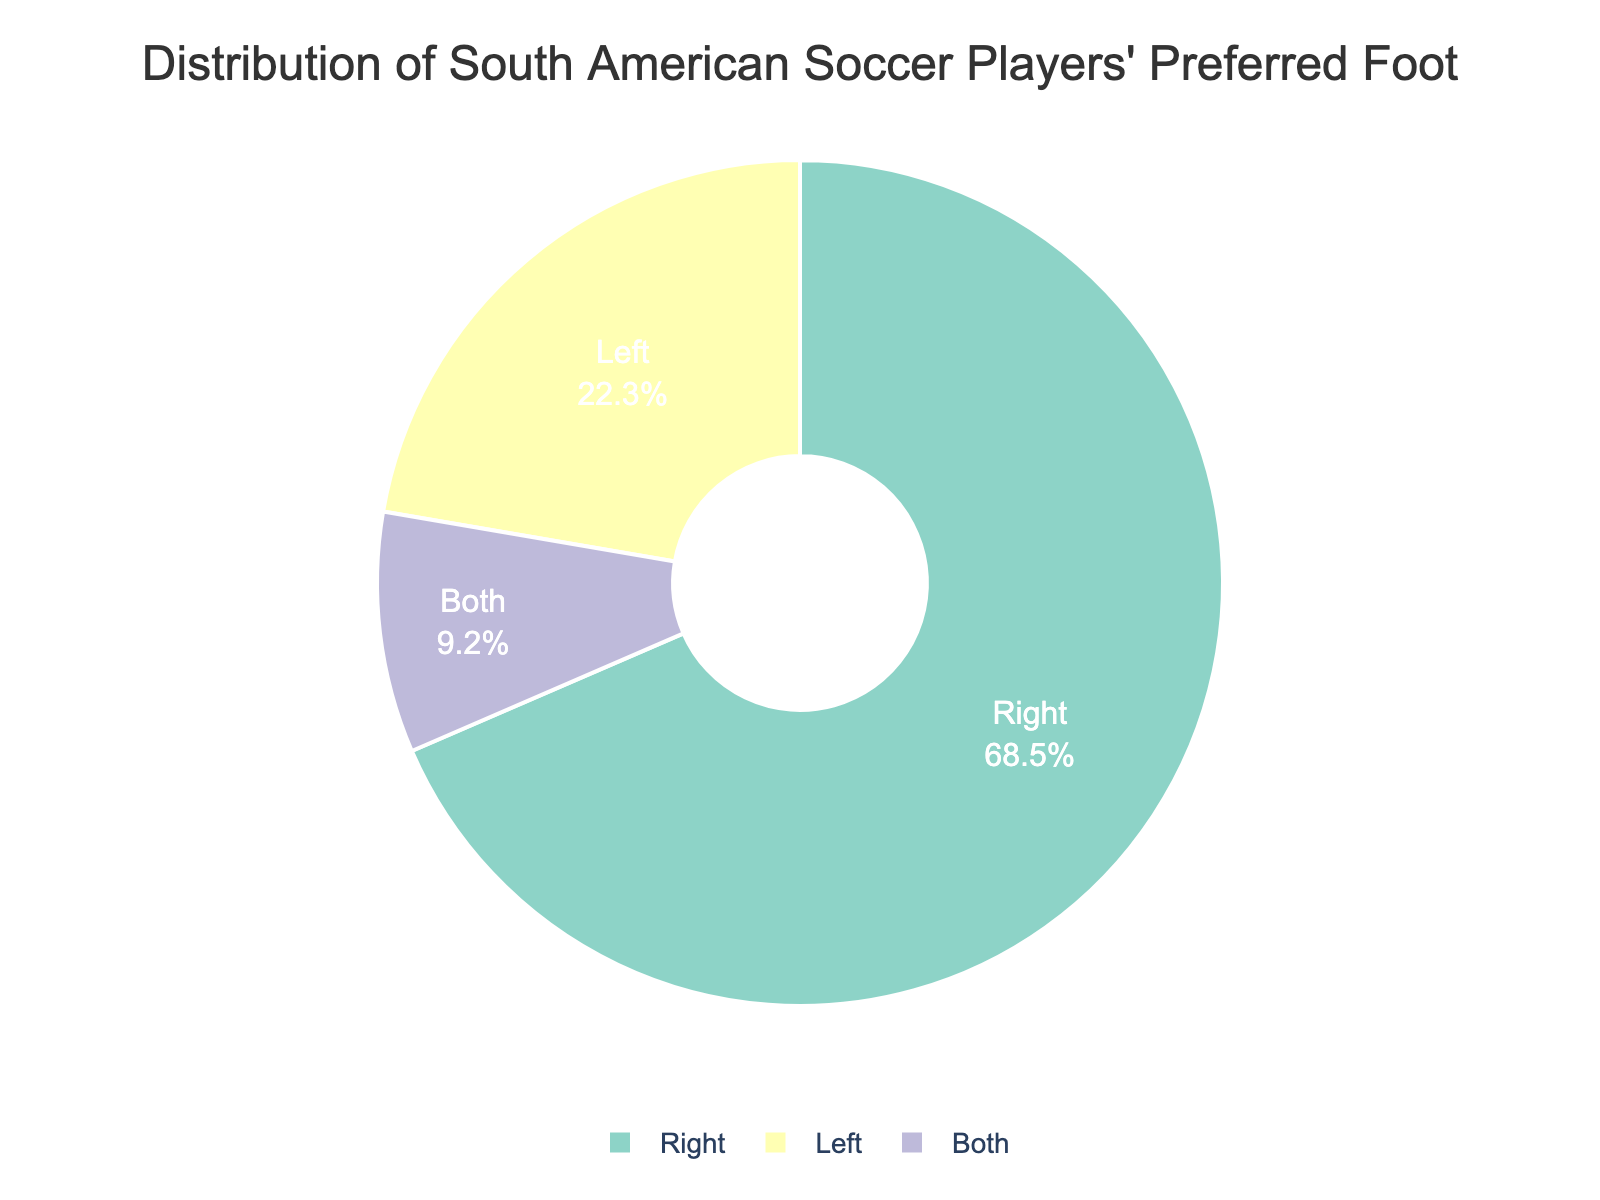which preferred foot is most common among South American soccer players? The pie chart shows the distribution of preferred feet among South American soccer players. The largest segment represents 68.5%, which corresponds to players who prefer using their right foot.
Answer: Right what is the total percentage of South American soccer players who use either left or both feet? The pie chart segments for left and both feet are 22.3% and 9.2%, respectively. Adding these percentages: 22.3% + 9.2% = 31.5%.
Answer: 31.5% how much larger is the percentage of right-footed players compared to left-footed players? From the chart, right-footed players constitute 68.5% and left-footed ones 22.3%. Subtracting these values gives: 68.5% - 22.3% = 46.2%.
Answer: 46.2% what color represents players who prefer both feet in the chart? The colors in the pie chart are visually distinct. By looking at which segment is labeled "Both" in the legend, you can identify its associated color.
Answer: (depends on the visual content which can't be provided here) is the percentage of right-footed players more than twice the percentage of left-footed players? The percentage of right-footed players is 68.5%, and the percentage of left-footed players is 22.3%. Twice the percentage of left-footed players would be 22.3% * 2 = 44.6%, which is less than 68.5%.
Answer: Yes if the data represents a league of 1,000 players, how many players use both feet? The percentage of players who use both feet is 9.2%. For 1,000 players: 1,000 * 9.2% = 92 players.
Answer: 92 compare the combined percentage of left-footed and both-footed players to right-footed players The combined percentage of left-footed (22.3%) and both-footed (9.2%) players is 31.5%. Comparing this with right-footed players (68.5%): 68.5% is more than 31.5%.
Answer: Right-footed players are more what fraction of players use their left foot? The percentage of left-footed players is 22.3%. To convert to a fraction: 22.3% / 100% = 223/1000, which simplifies to approximately 22/100 or 11/50.
Answer: 11/50 if 80% of a team prefers their right foot, how does this compare to the chart's distribution for right-footed players? The chart indicates 68.5% of South American players prefer their right foot. Comparing 80% with 68.5%, 80% is greater than the chart's percentage for right-footed players.
Answer: 80% is greater what is the ratio of players who prefer their right foot to those who use both feet? The percentage of right-footed players is 68.5%, and for both feet, it is 9.2%. The ratio is 68.5% / 9.2%, which simplifies to approximately 7.45:1.
Answer: 7.45:1 